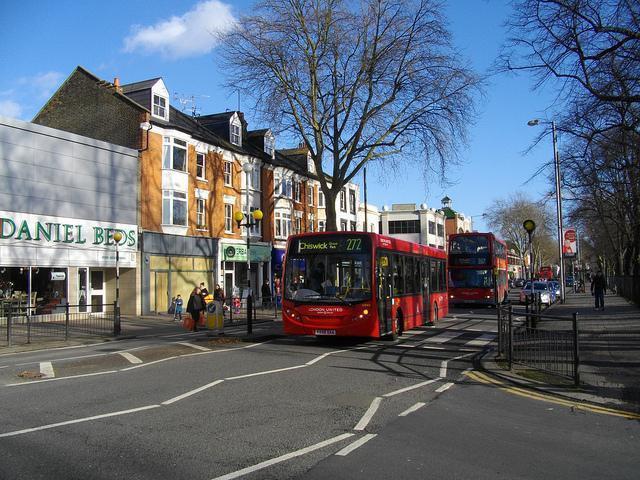How many buses are in the photo?
Give a very brief answer. 2. 